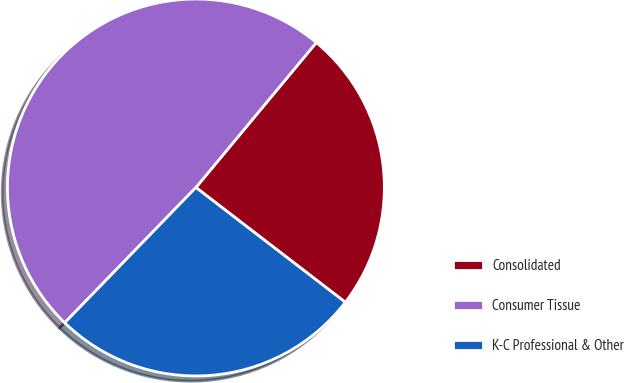<chart> <loc_0><loc_0><loc_500><loc_500><pie_chart><fcel>Consolidated<fcel>Consumer Tissue<fcel>K-C Professional & Other<nl><fcel>24.39%<fcel>48.78%<fcel>26.83%<nl></chart> 